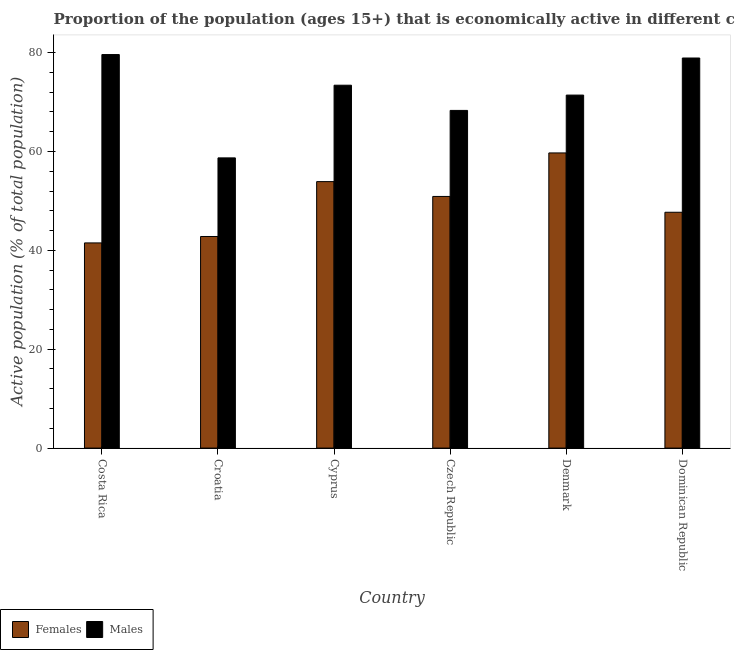How many different coloured bars are there?
Your answer should be very brief. 2. How many groups of bars are there?
Keep it short and to the point. 6. How many bars are there on the 1st tick from the left?
Offer a very short reply. 2. How many bars are there on the 3rd tick from the right?
Your answer should be very brief. 2. What is the percentage of economically active male population in Cyprus?
Provide a succinct answer. 73.4. Across all countries, what is the maximum percentage of economically active female population?
Provide a short and direct response. 59.7. Across all countries, what is the minimum percentage of economically active male population?
Ensure brevity in your answer.  58.7. In which country was the percentage of economically active male population minimum?
Your response must be concise. Croatia. What is the total percentage of economically active female population in the graph?
Provide a succinct answer. 296.5. What is the difference between the percentage of economically active male population in Croatia and that in Czech Republic?
Give a very brief answer. -9.6. What is the difference between the percentage of economically active male population in Denmark and the percentage of economically active female population in Dominican Republic?
Your response must be concise. 23.7. What is the average percentage of economically active female population per country?
Make the answer very short. 49.42. What is the difference between the percentage of economically active female population and percentage of economically active male population in Croatia?
Your answer should be compact. -15.9. In how many countries, is the percentage of economically active female population greater than 64 %?
Provide a short and direct response. 0. What is the ratio of the percentage of economically active male population in Costa Rica to that in Croatia?
Your answer should be very brief. 1.36. Is the percentage of economically active female population in Costa Rica less than that in Denmark?
Offer a very short reply. Yes. What is the difference between the highest and the second highest percentage of economically active male population?
Keep it short and to the point. 0.7. What is the difference between the highest and the lowest percentage of economically active female population?
Make the answer very short. 18.2. In how many countries, is the percentage of economically active female population greater than the average percentage of economically active female population taken over all countries?
Offer a very short reply. 3. Is the sum of the percentage of economically active male population in Cyprus and Dominican Republic greater than the maximum percentage of economically active female population across all countries?
Keep it short and to the point. Yes. What does the 2nd bar from the left in Dominican Republic represents?
Your answer should be compact. Males. What does the 1st bar from the right in Denmark represents?
Offer a very short reply. Males. Are all the bars in the graph horizontal?
Provide a short and direct response. No. What is the difference between two consecutive major ticks on the Y-axis?
Keep it short and to the point. 20. Are the values on the major ticks of Y-axis written in scientific E-notation?
Provide a short and direct response. No. Does the graph contain any zero values?
Your response must be concise. No. Where does the legend appear in the graph?
Make the answer very short. Bottom left. What is the title of the graph?
Give a very brief answer. Proportion of the population (ages 15+) that is economically active in different countries. Does "IMF nonconcessional" appear as one of the legend labels in the graph?
Ensure brevity in your answer.  No. What is the label or title of the X-axis?
Offer a terse response. Country. What is the label or title of the Y-axis?
Offer a terse response. Active population (% of total population). What is the Active population (% of total population) of Females in Costa Rica?
Your answer should be very brief. 41.5. What is the Active population (% of total population) in Males in Costa Rica?
Ensure brevity in your answer.  79.6. What is the Active population (% of total population) in Females in Croatia?
Your response must be concise. 42.8. What is the Active population (% of total population) of Males in Croatia?
Offer a very short reply. 58.7. What is the Active population (% of total population) of Females in Cyprus?
Offer a very short reply. 53.9. What is the Active population (% of total population) of Males in Cyprus?
Make the answer very short. 73.4. What is the Active population (% of total population) of Females in Czech Republic?
Offer a terse response. 50.9. What is the Active population (% of total population) in Males in Czech Republic?
Your answer should be compact. 68.3. What is the Active population (% of total population) in Females in Denmark?
Make the answer very short. 59.7. What is the Active population (% of total population) in Males in Denmark?
Ensure brevity in your answer.  71.4. What is the Active population (% of total population) in Females in Dominican Republic?
Your answer should be very brief. 47.7. What is the Active population (% of total population) in Males in Dominican Republic?
Offer a very short reply. 78.9. Across all countries, what is the maximum Active population (% of total population) in Females?
Keep it short and to the point. 59.7. Across all countries, what is the maximum Active population (% of total population) in Males?
Give a very brief answer. 79.6. Across all countries, what is the minimum Active population (% of total population) in Females?
Your answer should be compact. 41.5. Across all countries, what is the minimum Active population (% of total population) of Males?
Give a very brief answer. 58.7. What is the total Active population (% of total population) in Females in the graph?
Ensure brevity in your answer.  296.5. What is the total Active population (% of total population) of Males in the graph?
Ensure brevity in your answer.  430.3. What is the difference between the Active population (% of total population) in Males in Costa Rica and that in Croatia?
Your response must be concise. 20.9. What is the difference between the Active population (% of total population) in Males in Costa Rica and that in Cyprus?
Ensure brevity in your answer.  6.2. What is the difference between the Active population (% of total population) in Females in Costa Rica and that in Czech Republic?
Make the answer very short. -9.4. What is the difference between the Active population (% of total population) in Males in Costa Rica and that in Czech Republic?
Your answer should be compact. 11.3. What is the difference between the Active population (% of total population) in Females in Costa Rica and that in Denmark?
Ensure brevity in your answer.  -18.2. What is the difference between the Active population (% of total population) of Males in Costa Rica and that in Denmark?
Provide a succinct answer. 8.2. What is the difference between the Active population (% of total population) of Males in Costa Rica and that in Dominican Republic?
Provide a succinct answer. 0.7. What is the difference between the Active population (% of total population) of Females in Croatia and that in Cyprus?
Offer a very short reply. -11.1. What is the difference between the Active population (% of total population) in Males in Croatia and that in Cyprus?
Provide a succinct answer. -14.7. What is the difference between the Active population (% of total population) in Females in Croatia and that in Czech Republic?
Offer a terse response. -8.1. What is the difference between the Active population (% of total population) in Males in Croatia and that in Czech Republic?
Offer a very short reply. -9.6. What is the difference between the Active population (% of total population) in Females in Croatia and that in Denmark?
Your answer should be very brief. -16.9. What is the difference between the Active population (% of total population) of Males in Croatia and that in Dominican Republic?
Your answer should be very brief. -20.2. What is the difference between the Active population (% of total population) in Females in Cyprus and that in Denmark?
Give a very brief answer. -5.8. What is the difference between the Active population (% of total population) in Females in Czech Republic and that in Denmark?
Provide a short and direct response. -8.8. What is the difference between the Active population (% of total population) of Males in Czech Republic and that in Denmark?
Keep it short and to the point. -3.1. What is the difference between the Active population (% of total population) in Females in Czech Republic and that in Dominican Republic?
Your answer should be very brief. 3.2. What is the difference between the Active population (% of total population) in Males in Czech Republic and that in Dominican Republic?
Provide a short and direct response. -10.6. What is the difference between the Active population (% of total population) in Females in Denmark and that in Dominican Republic?
Provide a short and direct response. 12. What is the difference between the Active population (% of total population) in Males in Denmark and that in Dominican Republic?
Provide a short and direct response. -7.5. What is the difference between the Active population (% of total population) in Females in Costa Rica and the Active population (% of total population) in Males in Croatia?
Offer a terse response. -17.2. What is the difference between the Active population (% of total population) in Females in Costa Rica and the Active population (% of total population) in Males in Cyprus?
Provide a succinct answer. -31.9. What is the difference between the Active population (% of total population) in Females in Costa Rica and the Active population (% of total population) in Males in Czech Republic?
Your response must be concise. -26.8. What is the difference between the Active population (% of total population) of Females in Costa Rica and the Active population (% of total population) of Males in Denmark?
Make the answer very short. -29.9. What is the difference between the Active population (% of total population) of Females in Costa Rica and the Active population (% of total population) of Males in Dominican Republic?
Your answer should be very brief. -37.4. What is the difference between the Active population (% of total population) in Females in Croatia and the Active population (% of total population) in Males in Cyprus?
Ensure brevity in your answer.  -30.6. What is the difference between the Active population (% of total population) of Females in Croatia and the Active population (% of total population) of Males in Czech Republic?
Offer a very short reply. -25.5. What is the difference between the Active population (% of total population) in Females in Croatia and the Active population (% of total population) in Males in Denmark?
Provide a succinct answer. -28.6. What is the difference between the Active population (% of total population) in Females in Croatia and the Active population (% of total population) in Males in Dominican Republic?
Your response must be concise. -36.1. What is the difference between the Active population (% of total population) in Females in Cyprus and the Active population (% of total population) in Males in Czech Republic?
Provide a succinct answer. -14.4. What is the difference between the Active population (% of total population) in Females in Cyprus and the Active population (% of total population) in Males in Denmark?
Give a very brief answer. -17.5. What is the difference between the Active population (% of total population) in Females in Czech Republic and the Active population (% of total population) in Males in Denmark?
Provide a succinct answer. -20.5. What is the difference between the Active population (% of total population) of Females in Czech Republic and the Active population (% of total population) of Males in Dominican Republic?
Offer a very short reply. -28. What is the difference between the Active population (% of total population) in Females in Denmark and the Active population (% of total population) in Males in Dominican Republic?
Give a very brief answer. -19.2. What is the average Active population (% of total population) of Females per country?
Keep it short and to the point. 49.42. What is the average Active population (% of total population) of Males per country?
Provide a short and direct response. 71.72. What is the difference between the Active population (% of total population) in Females and Active population (% of total population) in Males in Costa Rica?
Your answer should be compact. -38.1. What is the difference between the Active population (% of total population) in Females and Active population (% of total population) in Males in Croatia?
Provide a short and direct response. -15.9. What is the difference between the Active population (% of total population) of Females and Active population (% of total population) of Males in Cyprus?
Keep it short and to the point. -19.5. What is the difference between the Active population (% of total population) in Females and Active population (% of total population) in Males in Czech Republic?
Ensure brevity in your answer.  -17.4. What is the difference between the Active population (% of total population) in Females and Active population (% of total population) in Males in Denmark?
Provide a short and direct response. -11.7. What is the difference between the Active population (% of total population) of Females and Active population (% of total population) of Males in Dominican Republic?
Make the answer very short. -31.2. What is the ratio of the Active population (% of total population) of Females in Costa Rica to that in Croatia?
Give a very brief answer. 0.97. What is the ratio of the Active population (% of total population) in Males in Costa Rica to that in Croatia?
Give a very brief answer. 1.36. What is the ratio of the Active population (% of total population) of Females in Costa Rica to that in Cyprus?
Keep it short and to the point. 0.77. What is the ratio of the Active population (% of total population) in Males in Costa Rica to that in Cyprus?
Your answer should be very brief. 1.08. What is the ratio of the Active population (% of total population) of Females in Costa Rica to that in Czech Republic?
Offer a terse response. 0.82. What is the ratio of the Active population (% of total population) in Males in Costa Rica to that in Czech Republic?
Offer a terse response. 1.17. What is the ratio of the Active population (% of total population) of Females in Costa Rica to that in Denmark?
Your answer should be compact. 0.7. What is the ratio of the Active population (% of total population) of Males in Costa Rica to that in Denmark?
Provide a succinct answer. 1.11. What is the ratio of the Active population (% of total population) of Females in Costa Rica to that in Dominican Republic?
Ensure brevity in your answer.  0.87. What is the ratio of the Active population (% of total population) in Males in Costa Rica to that in Dominican Republic?
Offer a very short reply. 1.01. What is the ratio of the Active population (% of total population) in Females in Croatia to that in Cyprus?
Your answer should be very brief. 0.79. What is the ratio of the Active population (% of total population) of Males in Croatia to that in Cyprus?
Offer a terse response. 0.8. What is the ratio of the Active population (% of total population) in Females in Croatia to that in Czech Republic?
Offer a very short reply. 0.84. What is the ratio of the Active population (% of total population) in Males in Croatia to that in Czech Republic?
Your response must be concise. 0.86. What is the ratio of the Active population (% of total population) of Females in Croatia to that in Denmark?
Offer a terse response. 0.72. What is the ratio of the Active population (% of total population) in Males in Croatia to that in Denmark?
Give a very brief answer. 0.82. What is the ratio of the Active population (% of total population) of Females in Croatia to that in Dominican Republic?
Your answer should be very brief. 0.9. What is the ratio of the Active population (% of total population) in Males in Croatia to that in Dominican Republic?
Offer a very short reply. 0.74. What is the ratio of the Active population (% of total population) of Females in Cyprus to that in Czech Republic?
Offer a very short reply. 1.06. What is the ratio of the Active population (% of total population) of Males in Cyprus to that in Czech Republic?
Keep it short and to the point. 1.07. What is the ratio of the Active population (% of total population) in Females in Cyprus to that in Denmark?
Your response must be concise. 0.9. What is the ratio of the Active population (% of total population) of Males in Cyprus to that in Denmark?
Offer a very short reply. 1.03. What is the ratio of the Active population (% of total population) of Females in Cyprus to that in Dominican Republic?
Offer a very short reply. 1.13. What is the ratio of the Active population (% of total population) of Males in Cyprus to that in Dominican Republic?
Your answer should be compact. 0.93. What is the ratio of the Active population (% of total population) of Females in Czech Republic to that in Denmark?
Offer a very short reply. 0.85. What is the ratio of the Active population (% of total population) in Males in Czech Republic to that in Denmark?
Provide a succinct answer. 0.96. What is the ratio of the Active population (% of total population) in Females in Czech Republic to that in Dominican Republic?
Keep it short and to the point. 1.07. What is the ratio of the Active population (% of total population) of Males in Czech Republic to that in Dominican Republic?
Your answer should be very brief. 0.87. What is the ratio of the Active population (% of total population) of Females in Denmark to that in Dominican Republic?
Keep it short and to the point. 1.25. What is the ratio of the Active population (% of total population) of Males in Denmark to that in Dominican Republic?
Offer a very short reply. 0.9. What is the difference between the highest and the second highest Active population (% of total population) in Females?
Offer a terse response. 5.8. What is the difference between the highest and the lowest Active population (% of total population) of Females?
Your answer should be compact. 18.2. What is the difference between the highest and the lowest Active population (% of total population) of Males?
Your answer should be very brief. 20.9. 